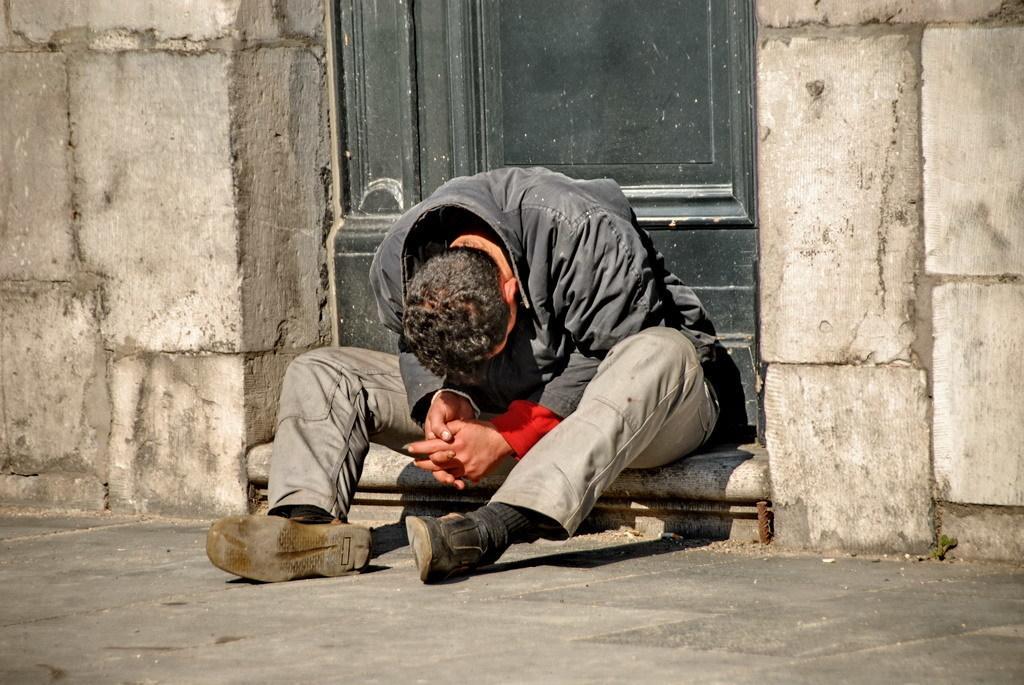Please provide a concise description of this image. In this image there is a person sitting in front of the door, beside the door there is a wall. 